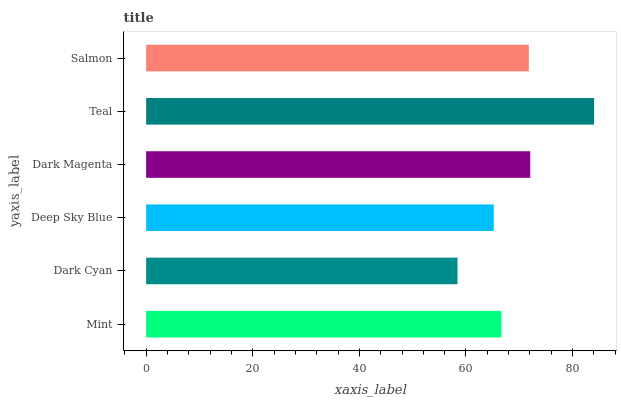Is Dark Cyan the minimum?
Answer yes or no. Yes. Is Teal the maximum?
Answer yes or no. Yes. Is Deep Sky Blue the minimum?
Answer yes or no. No. Is Deep Sky Blue the maximum?
Answer yes or no. No. Is Deep Sky Blue greater than Dark Cyan?
Answer yes or no. Yes. Is Dark Cyan less than Deep Sky Blue?
Answer yes or no. Yes. Is Dark Cyan greater than Deep Sky Blue?
Answer yes or no. No. Is Deep Sky Blue less than Dark Cyan?
Answer yes or no. No. Is Salmon the high median?
Answer yes or no. Yes. Is Mint the low median?
Answer yes or no. Yes. Is Dark Magenta the high median?
Answer yes or no. No. Is Teal the low median?
Answer yes or no. No. 